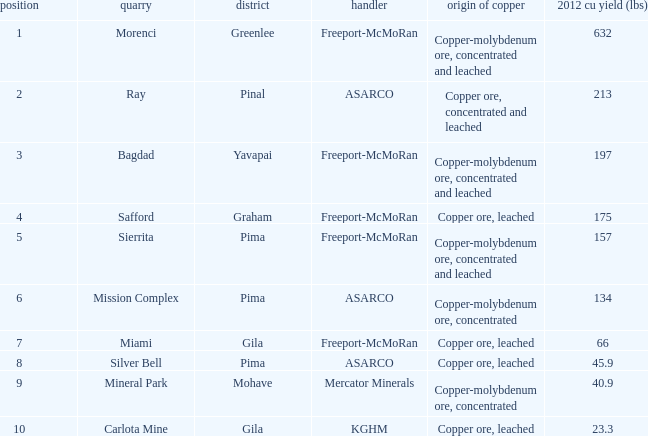What's the name of the operator who has the mission complex mine and has a 2012 Cu Production (lbs) larger than 23.3? ASARCO. 